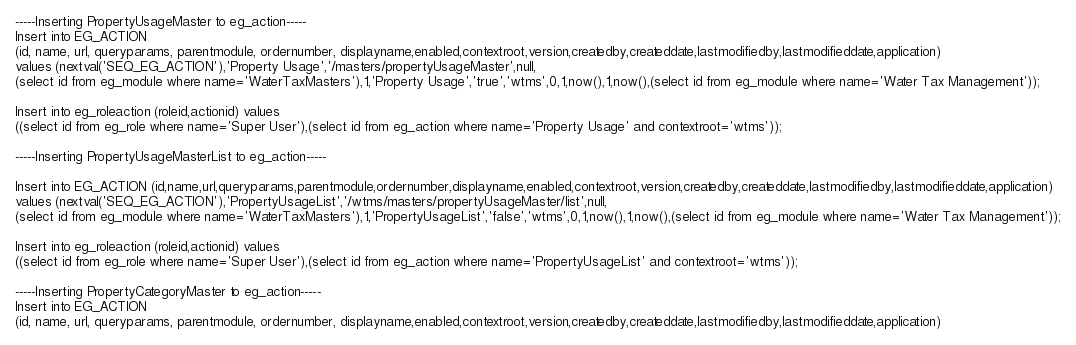Convert code to text. <code><loc_0><loc_0><loc_500><loc_500><_SQL_>-----Inserting PropertyUsageMaster to eg_action-----
Insert into EG_ACTION 
(id, name, url, queryparams, parentmodule, ordernumber, displayname,enabled,contextroot,version,createdby,createddate,lastmodifiedby,lastmodifieddate,application) 
values (nextval('SEQ_EG_ACTION'),'Property Usage','/masters/propertyUsageMaster',null,
(select id from eg_module where name='WaterTaxMasters'),1,'Property Usage','true','wtms',0,1,now(),1,now(),(select id from eg_module where name='Water Tax Management'));

Insert into eg_roleaction (roleid,actionid) values 
((select id from eg_role where name='Super User'),(select id from eg_action where name='Property Usage' and contextroot='wtms'));

-----Inserting PropertyUsageMasterList to eg_action-----

Insert into EG_ACTION (id,name,url,queryparams,parentmodule,ordernumber,displayname,enabled,contextroot,version,createdby,createddate,lastmodifiedby,lastmodifieddate,application)
values (nextval('SEQ_EG_ACTION'),'PropertyUsageList','/wtms/masters/propertyUsageMaster/list',null,
(select id from eg_module where name='WaterTaxMasters'),1,'PropertyUsageList','false','wtms',0,1,now(),1,now(),(select id from eg_module where name='Water Tax Management'));

Insert into eg_roleaction (roleid,actionid) values 
((select id from eg_role where name='Super User'),(select id from eg_action where name='PropertyUsageList' and contextroot='wtms'));

-----Inserting PropertyCategoryMaster to eg_action-----
Insert into EG_ACTION 
(id, name, url, queryparams, parentmodule, ordernumber, displayname,enabled,contextroot,version,createdby,createddate,lastmodifiedby,lastmodifieddate,application) </code> 